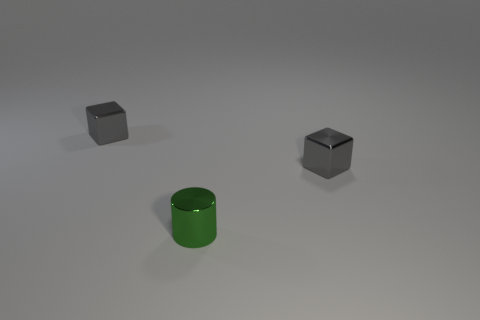What might be the purpose of these objects? It's difficult to determine the specific purpose without additional context. These objects could be part of a visual composition exercise or 3D render demonstrating shapes, materials, and shadows. They might also represent simplistic models used for educational purposes in geometry or physics. 